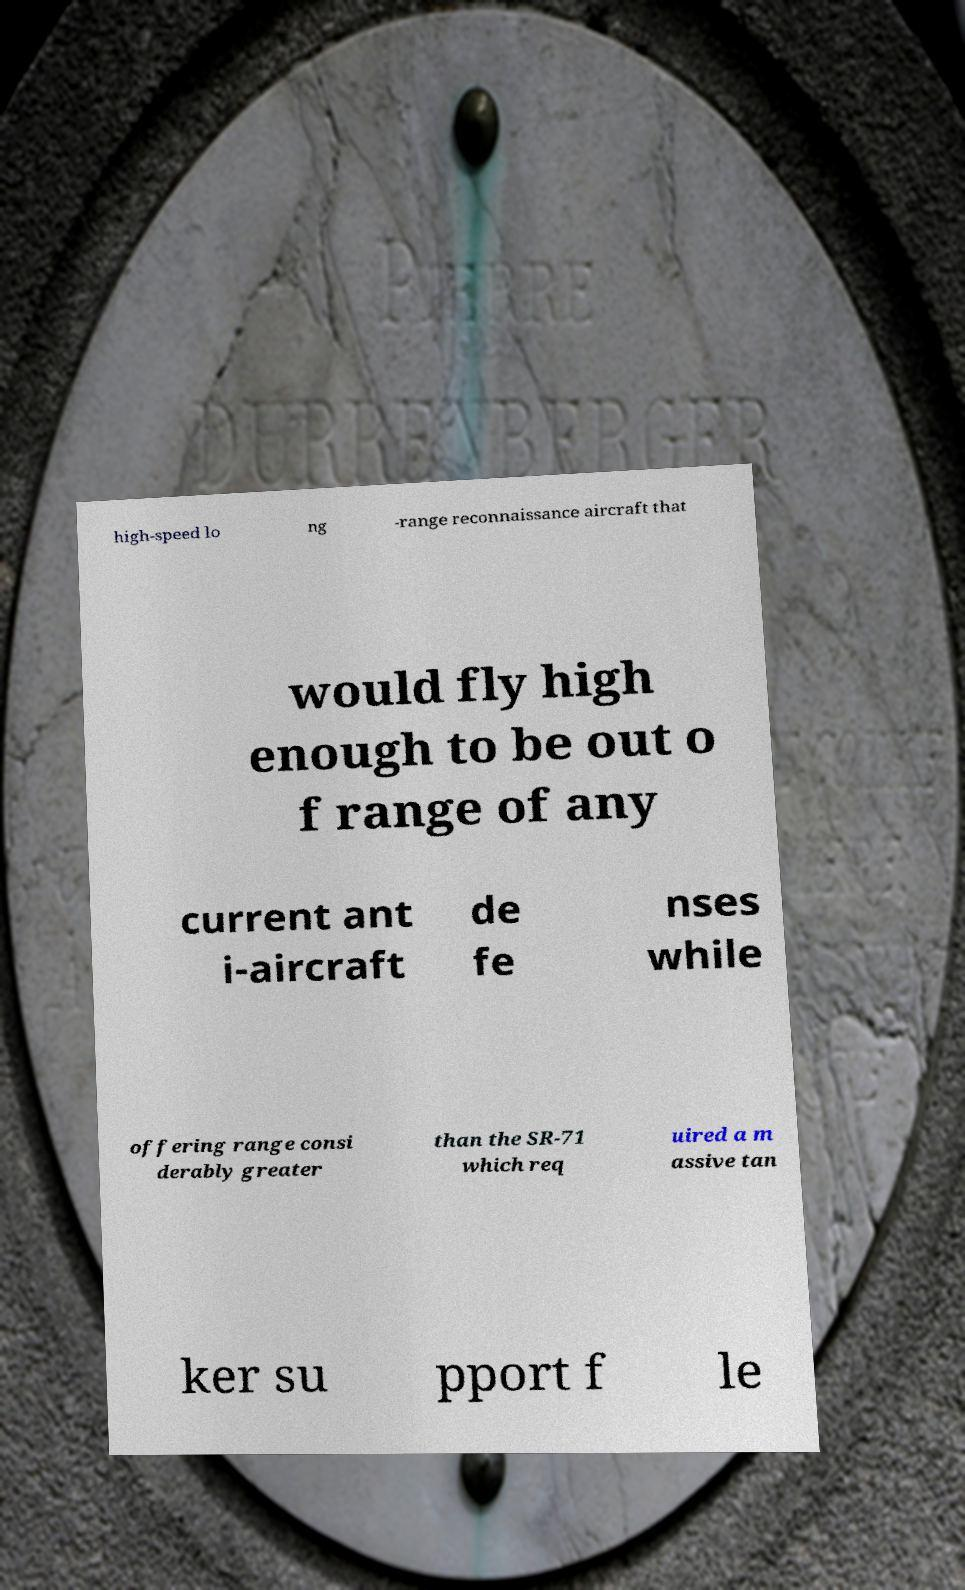There's text embedded in this image that I need extracted. Can you transcribe it verbatim? high-speed lo ng -range reconnaissance aircraft that would fly high enough to be out o f range of any current ant i-aircraft de fe nses while offering range consi derably greater than the SR-71 which req uired a m assive tan ker su pport f le 